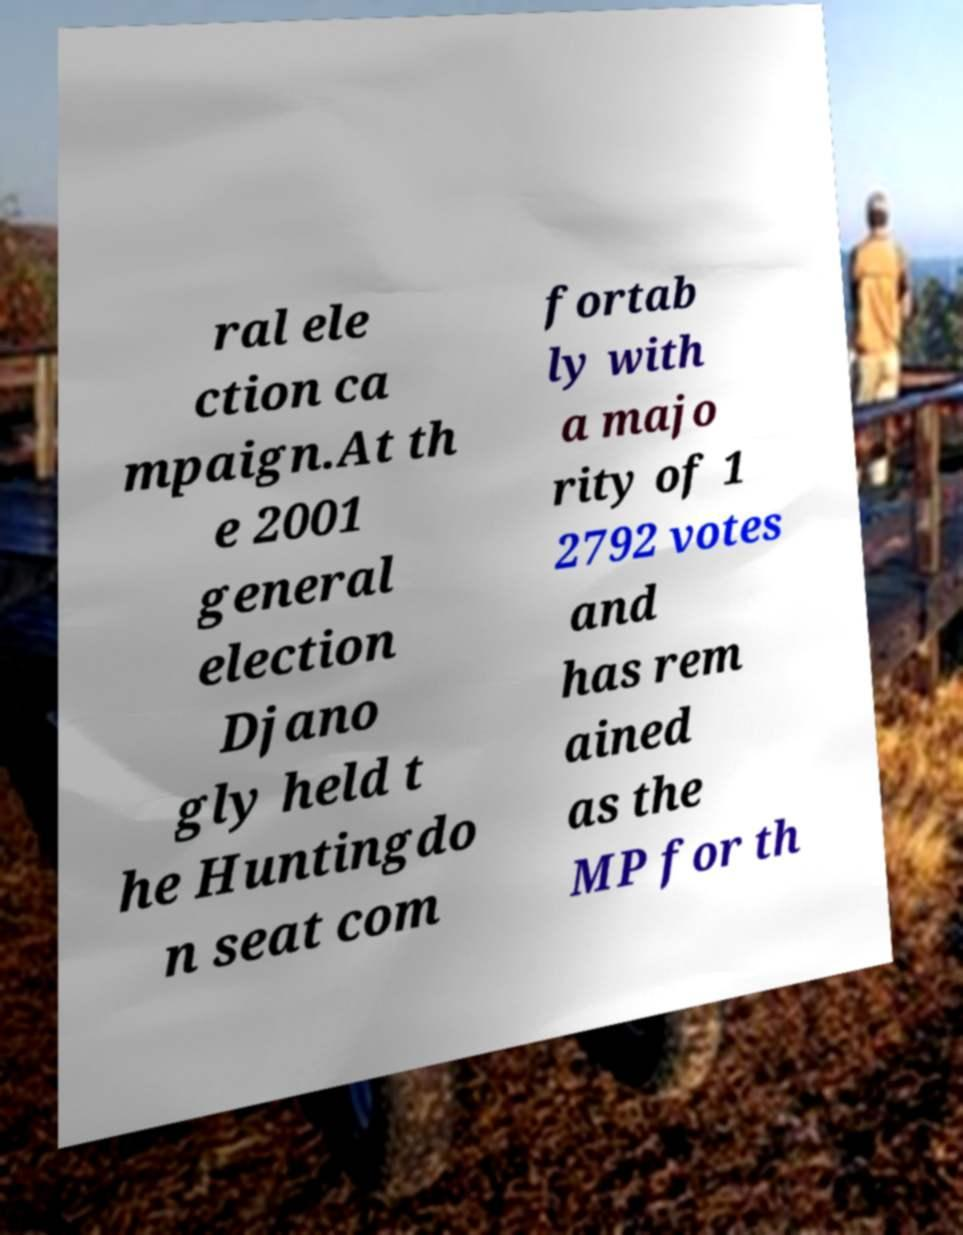Can you read and provide the text displayed in the image?This photo seems to have some interesting text. Can you extract and type it out for me? ral ele ction ca mpaign.At th e 2001 general election Djano gly held t he Huntingdo n seat com fortab ly with a majo rity of 1 2792 votes and has rem ained as the MP for th 